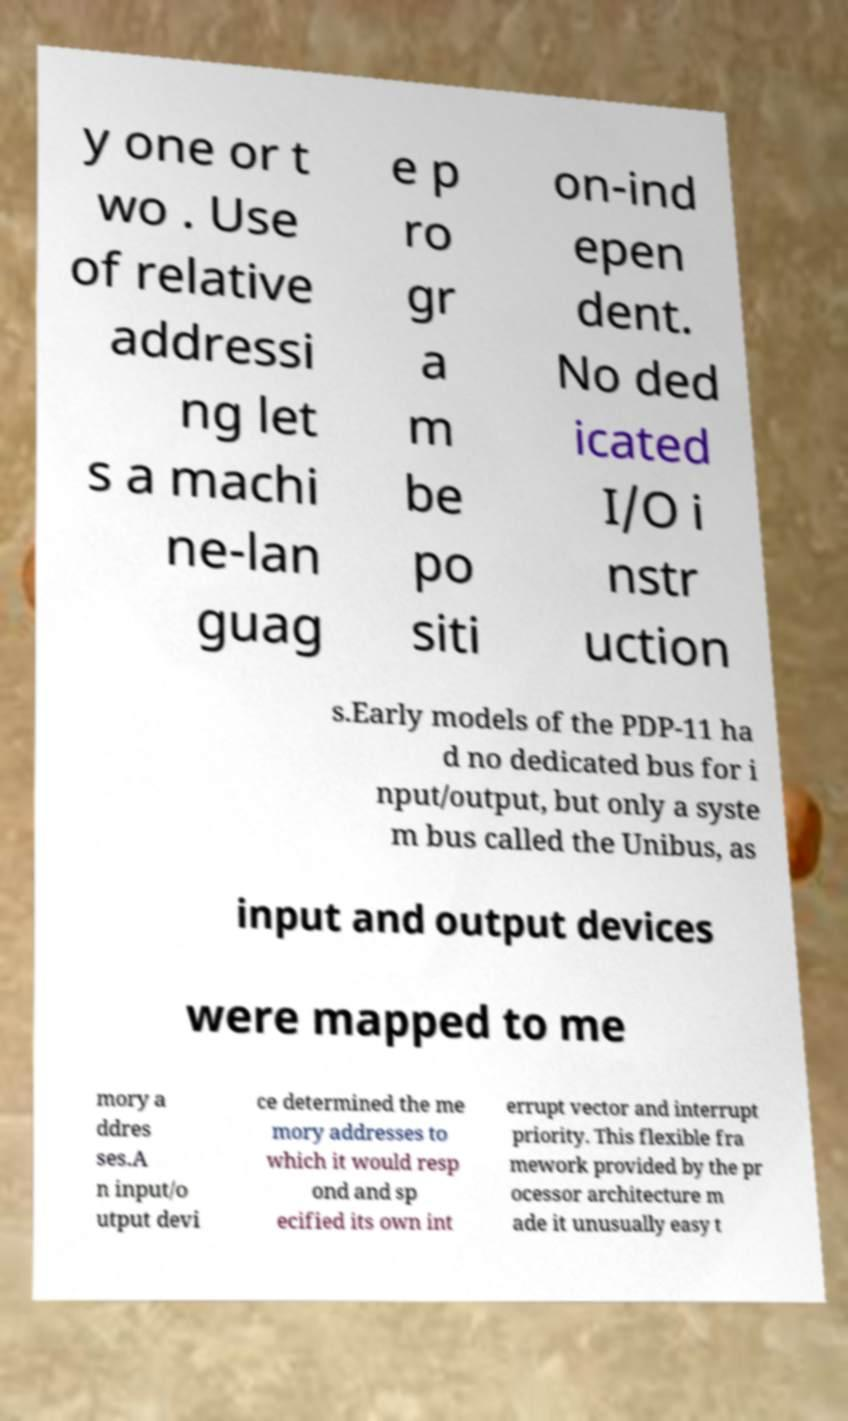Can you read and provide the text displayed in the image?This photo seems to have some interesting text. Can you extract and type it out for me? y one or t wo . Use of relative addressi ng let s a machi ne-lan guag e p ro gr a m be po siti on-ind epen dent. No ded icated I/O i nstr uction s.Early models of the PDP-11 ha d no dedicated bus for i nput/output, but only a syste m bus called the Unibus, as input and output devices were mapped to me mory a ddres ses.A n input/o utput devi ce determined the me mory addresses to which it would resp ond and sp ecified its own int errupt vector and interrupt priority. This flexible fra mework provided by the pr ocessor architecture m ade it unusually easy t 